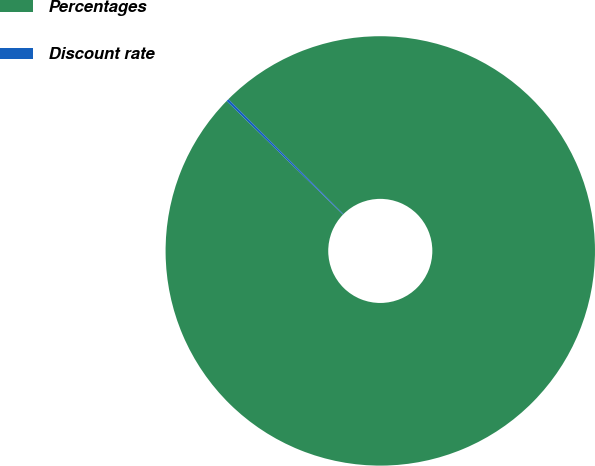Convert chart to OTSL. <chart><loc_0><loc_0><loc_500><loc_500><pie_chart><fcel>Percentages<fcel>Discount rate<nl><fcel>99.81%<fcel>0.19%<nl></chart> 